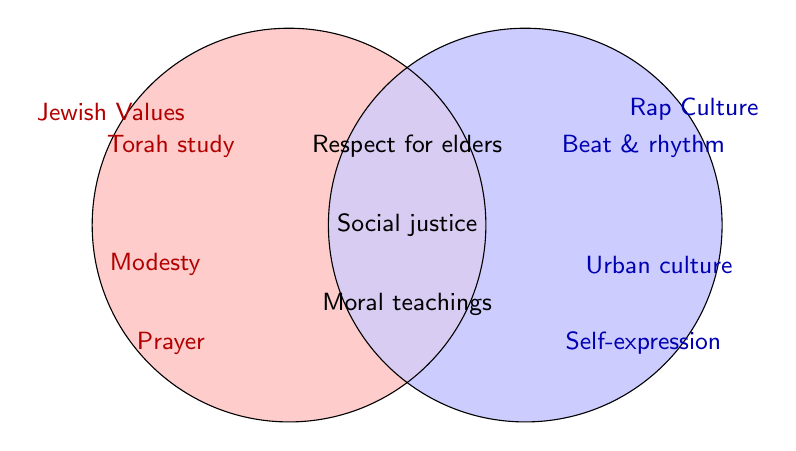What values are common to both Jewish traditions and rap culture? We need to look at the intersection of the two circles where the values of both Jewish traditions and rap culture overlap. The elements in this intersection are: “Respect for elders,” “Social justice,” and “Moral teachings.”
Answer: Respect for elders, Social justice, Moral teachings Which component is unique to the Jewish values but not found in rap culture? We need to find elements in the circle labeled "Jewish Values" that are not in the intersection with "Rap Culture." These include “Torah study,” “Modesty,” “Sabbath observance,” “Kosher diet,” and “Charitable giving.”
Answer: Torah study, Modesty, Sabbath observance, Kosher diet, Charitable giving What is a shared value underlined by both traditions that focuses on the well-being of society? Identify values in the intersection relating to societal well-being. The shared value here is “Social justice.”
Answer: Social justice Name any value specific to rap culture that is not present in Jewish values. Look at the values in the “Rap Culture” section that are not in the intersection with “Jewish Values.” These include “Beat and rhythm,” “Urban culture,” “Storytelling,” and “Self-expression.”
Answer: Beat and rhythm, Urban culture, Storytelling, Self-expression How many values are exclusive to the Jewish tradition? Count the elements within the "Jewish Values" circle but outside the intersection. These items are: “Torah study,” “Modesty,” “Sabbath observance,” “Kosher diet,” and “Charitable giving.” The total number is 5.
Answer: 5 Which value present in the figure emphasizes the importance of maintaining moral standards and is shared by both traditions? Look at the intersection values for anything emphasizing moral standards. The value is “Moral teachings.”
Answer: Moral teachings What unique element does rap culture explicitly bring to the table that is not traditionally emphasized in Jewish values? Use values exclusively in the "Rap Culture" circle. Options would be “Beat and rhythm,” “Urban culture,” “Storytelling,” and “Self-expression.”
Answer: Beat and rhythm, Urban culture, Storytelling, Self-expression What value related to 'community' is found exclusively in Jewish traditions and not in rap culture? Check exclusive values in the "Jewish Values" circle for anything community related. “Charitable giving” emphasizes community support and is exclusive to Jewish traditions.
Answer: Charitable giving Identify a value from the figure that focuses on expressing emotions and thoughts verbally, and state which tradition it belongs to. Look for values relating to verbal expression in either circle. “Storytelling” belongs to “Rap Culture.”
Answer: Storytelling 